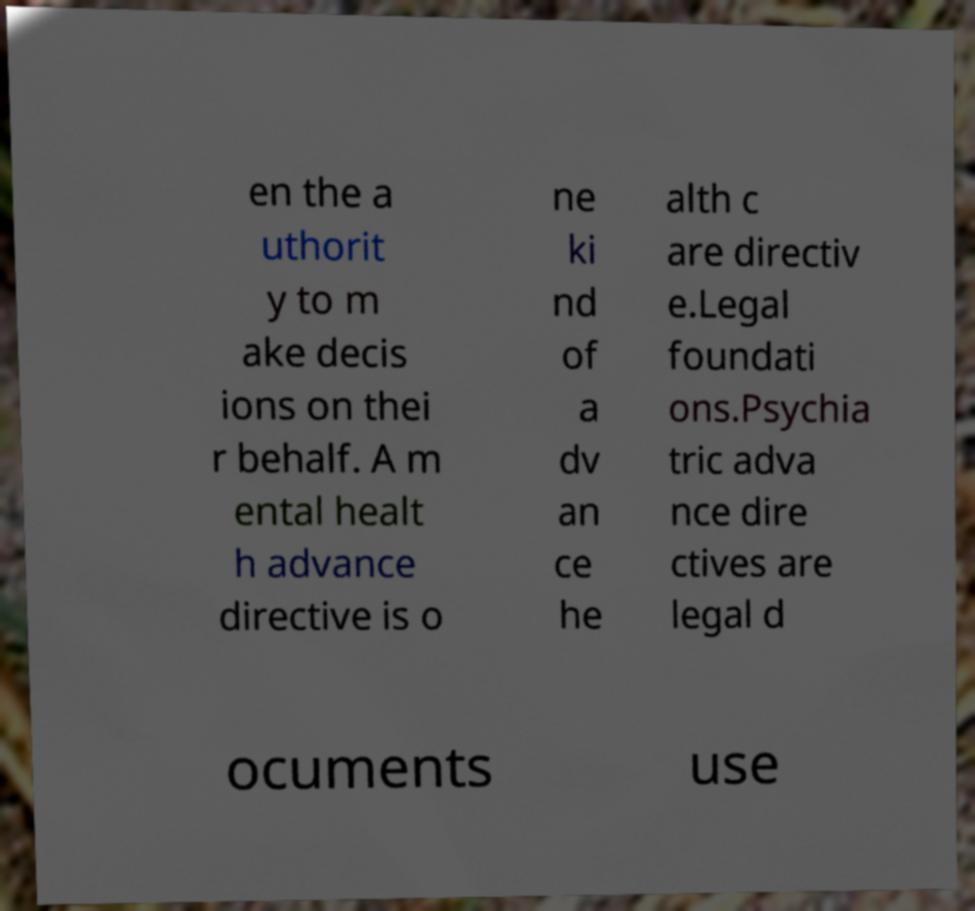I need the written content from this picture converted into text. Can you do that? en the a uthorit y to m ake decis ions on thei r behalf. A m ental healt h advance directive is o ne ki nd of a dv an ce he alth c are directiv e.Legal foundati ons.Psychia tric adva nce dire ctives are legal d ocuments use 